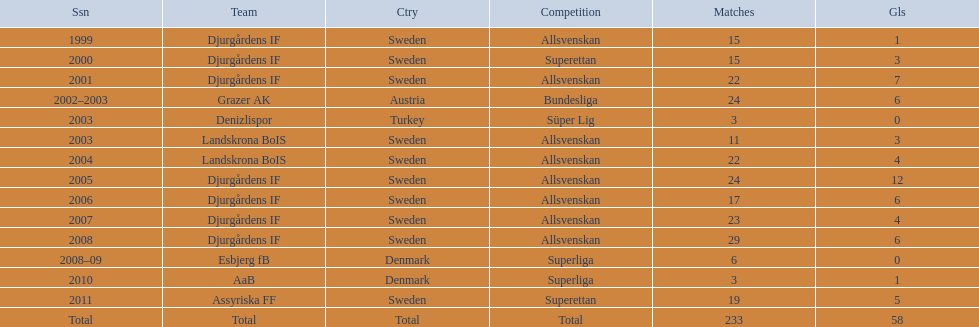How many matches overall were there? 233. Can you parse all the data within this table? {'header': ['Ssn', 'Team', 'Ctry', 'Competition', 'Matches', 'Gls'], 'rows': [['1999', 'Djurgårdens IF', 'Sweden', 'Allsvenskan', '15', '1'], ['2000', 'Djurgårdens IF', 'Sweden', 'Superettan', '15', '3'], ['2001', 'Djurgårdens IF', 'Sweden', 'Allsvenskan', '22', '7'], ['2002–2003', 'Grazer AK', 'Austria', 'Bundesliga', '24', '6'], ['2003', 'Denizlispor', 'Turkey', 'Süper Lig', '3', '0'], ['2003', 'Landskrona BoIS', 'Sweden', 'Allsvenskan', '11', '3'], ['2004', 'Landskrona BoIS', 'Sweden', 'Allsvenskan', '22', '4'], ['2005', 'Djurgårdens IF', 'Sweden', 'Allsvenskan', '24', '12'], ['2006', 'Djurgårdens IF', 'Sweden', 'Allsvenskan', '17', '6'], ['2007', 'Djurgårdens IF', 'Sweden', 'Allsvenskan', '23', '4'], ['2008', 'Djurgårdens IF', 'Sweden', 'Allsvenskan', '29', '6'], ['2008–09', 'Esbjerg fB', 'Denmark', 'Superliga', '6', '0'], ['2010', 'AaB', 'Denmark', 'Superliga', '3', '1'], ['2011', 'Assyriska FF', 'Sweden', 'Superettan', '19', '5'], ['Total', 'Total', 'Total', 'Total', '233', '58']]} 